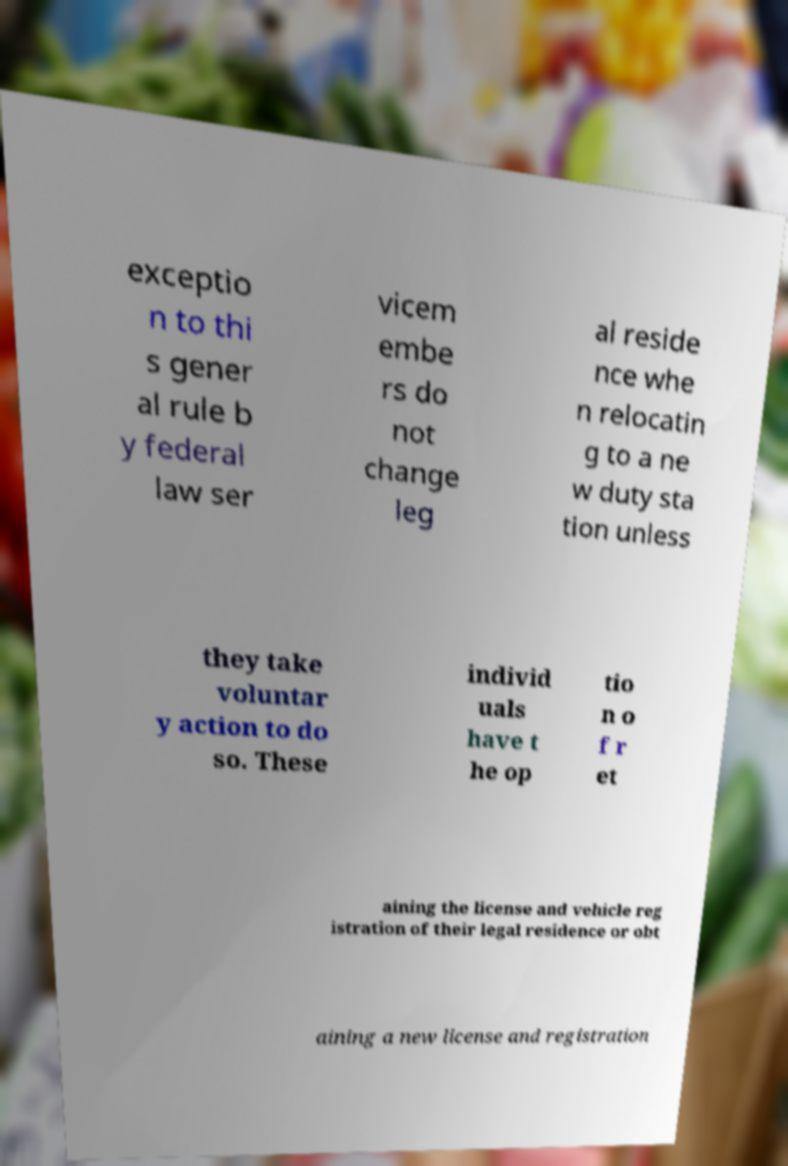There's text embedded in this image that I need extracted. Can you transcribe it verbatim? exceptio n to thi s gener al rule b y federal law ser vicem embe rs do not change leg al reside nce whe n relocatin g to a ne w duty sta tion unless they take voluntar y action to do so. These individ uals have t he op tio n o f r et aining the license and vehicle reg istration of their legal residence or obt aining a new license and registration 